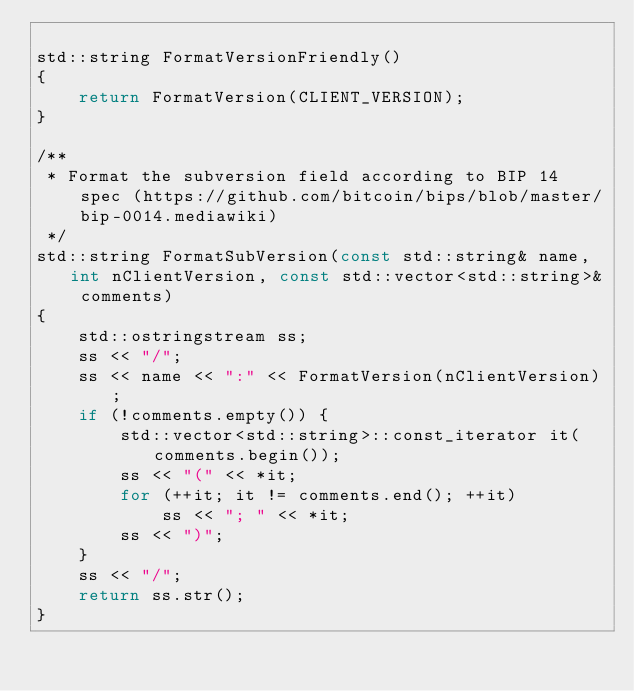<code> <loc_0><loc_0><loc_500><loc_500><_C++_>
std::string FormatVersionFriendly()
{
    return FormatVersion(CLIENT_VERSION);
}

/** 
 * Format the subversion field according to BIP 14 spec (https://github.com/bitcoin/bips/blob/master/bip-0014.mediawiki) 
 */
std::string FormatSubVersion(const std::string& name, int nClientVersion, const std::vector<std::string>& comments)
{
    std::ostringstream ss;
    ss << "/";
    ss << name << ":" << FormatVersion(nClientVersion);
    if (!comments.empty()) {
        std::vector<std::string>::const_iterator it(comments.begin());
        ss << "(" << *it;
        for (++it; it != comments.end(); ++it)
            ss << "; " << *it;
        ss << ")";
    }
    ss << "/";
    return ss.str();
}
</code> 